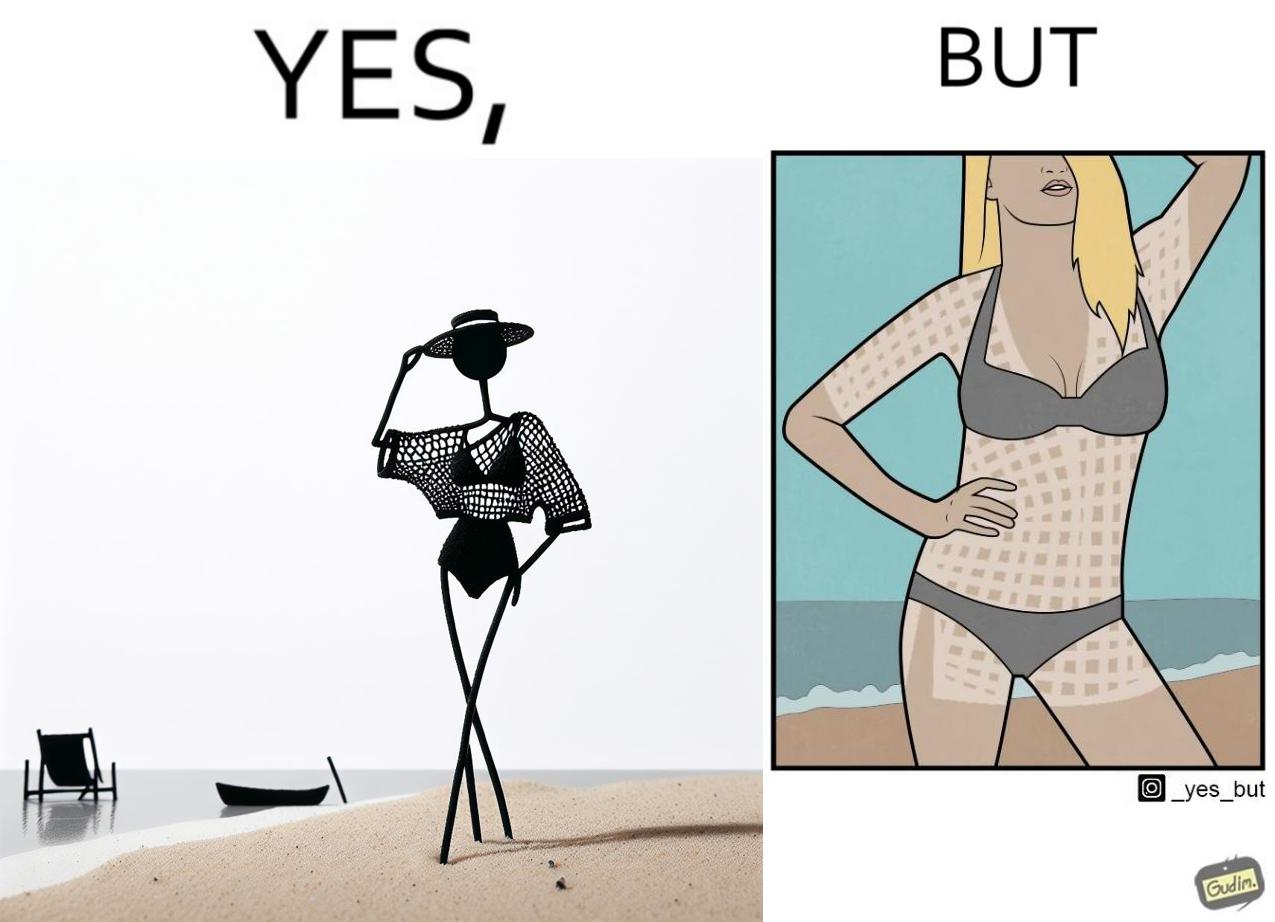Explain the humor or irony in this image. Women wear netted tops while out in the sun on the beach as a beachwear, but when the person removes it, the skin is tanned in the same netted pattern looks weird, and goes against the purpose of using it as beachwear 